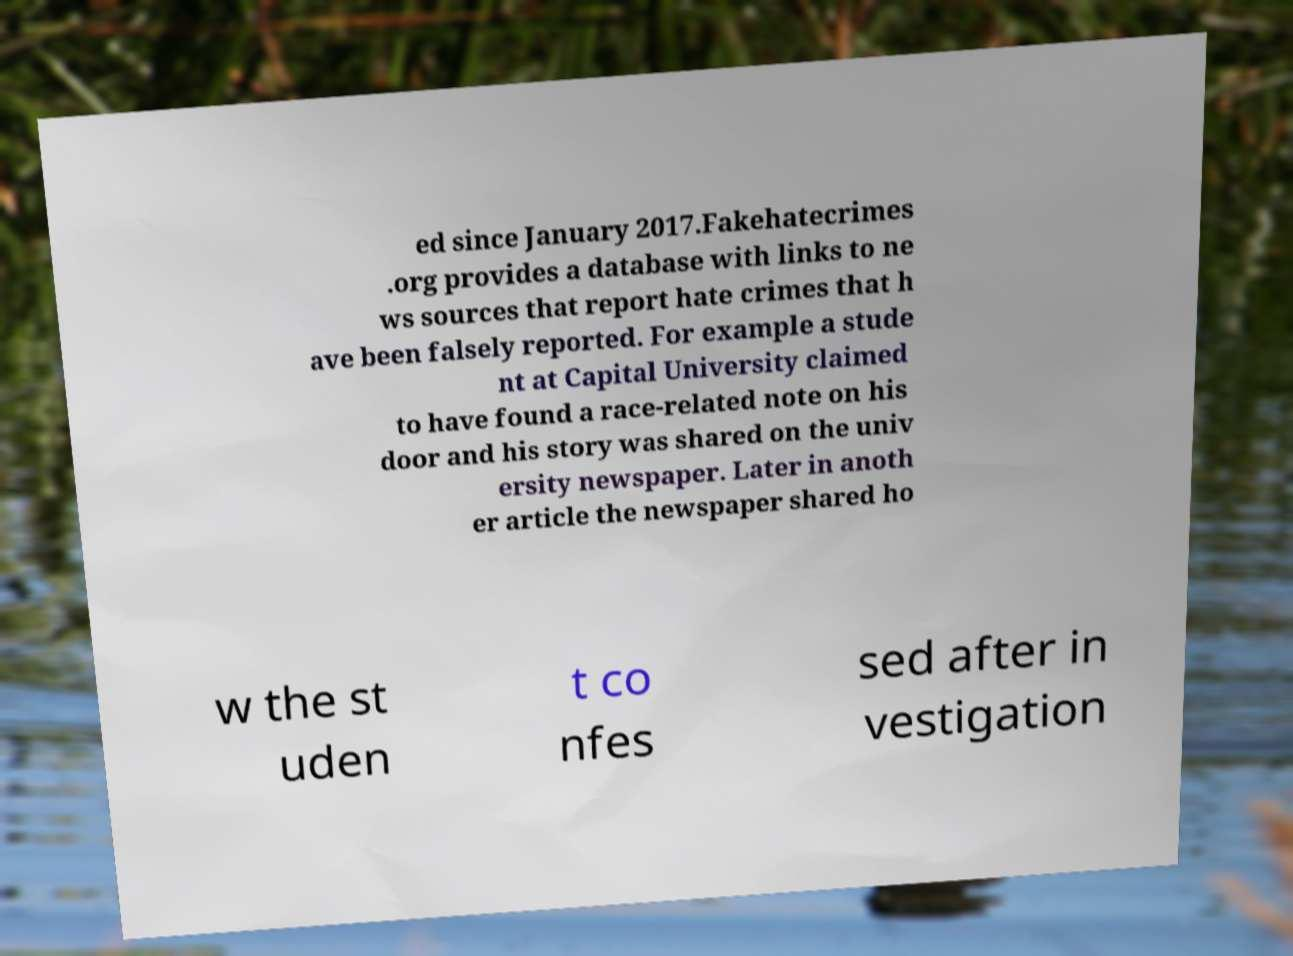What messages or text are displayed in this image? I need them in a readable, typed format. ed since January 2017.Fakehatecrimes .org provides a database with links to ne ws sources that report hate crimes that h ave been falsely reported. For example a stude nt at Capital University claimed to have found a race-related note on his door and his story was shared on the univ ersity newspaper. Later in anoth er article the newspaper shared ho w the st uden t co nfes sed after in vestigation 